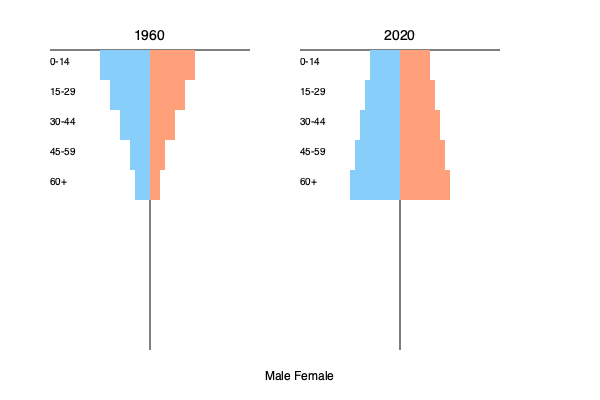Analyze the demographic shifts in the U.S. population as depicted in the population pyramids for 1960 and 2020. Discuss the potential implications of these changes on social policies, economic strategies, and political landscapes during this period. How might these shifts have influenced presidential campaign strategies and policy priorities? To analyze the demographic shifts and their implications, let's examine the population pyramids step-by-step:

1. Shape change:
   - 1960: Pyramid-shaped, with a wide base and narrow top.
   - 2020: More rectangular, with a relatively even distribution across age groups.

2. Age distribution changes:
   - 0-14 age group: Decreased significantly from 1960 to 2020.
   - 15-29 and 30-44 age groups: Relatively stable.
   - 45-59 and 60+ age groups: Increased substantially from 1960 to 2020.

3. Implications:

   a) Social policies:
      - Increased demand for healthcare and long-term care services for the elderly.
      - Potential strain on Social Security and Medicare systems.
      - Shift in education funding priorities from primary to higher education and adult learning.

   b) Economic strategies:
      - Labor force composition changes, with a larger proportion of older workers.
      - Increased focus on technology and automation to compensate for potential labor shortages.
      - Shift in consumer markets towards products and services for older demographics.

   c) Political landscapes:
      - Growing influence of older voters on election outcomes.
      - Increased importance of issues such as healthcare reform, retirement security, and age discrimination.

4. Impact on presidential campaigns and policy priorities:
   - Greater emphasis on healthcare reform and Social Security sustainability.
   - Increased focus on policies supporting working families and childcare.
   - More attention to issues affecting older voters, such as prescription drug costs and elder care.
   - Potential generational conflicts in policy priorities, requiring careful balancing acts.

5. Long-term considerations:
   - Need for immigration reform to address potential labor shortages.
   - Importance of technological innovation and productivity improvements to support an aging population.
   - Potential shifts in global economic competitiveness due to demographic changes.

These demographic shifts have likely led to a more complex political landscape, requiring presidents and policymakers to address the needs of a more diverse age distribution while balancing the interests of different generations.
Answer: Aging population with more balanced age distribution, leading to shifts in social policies, economic strategies, and political priorities focused on healthcare, retirement, and intergenerational equity. 